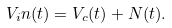Convert formula to latex. <formula><loc_0><loc_0><loc_500><loc_500>V _ { i } n ( t ) = V _ { c } ( t ) + N ( t ) .</formula> 